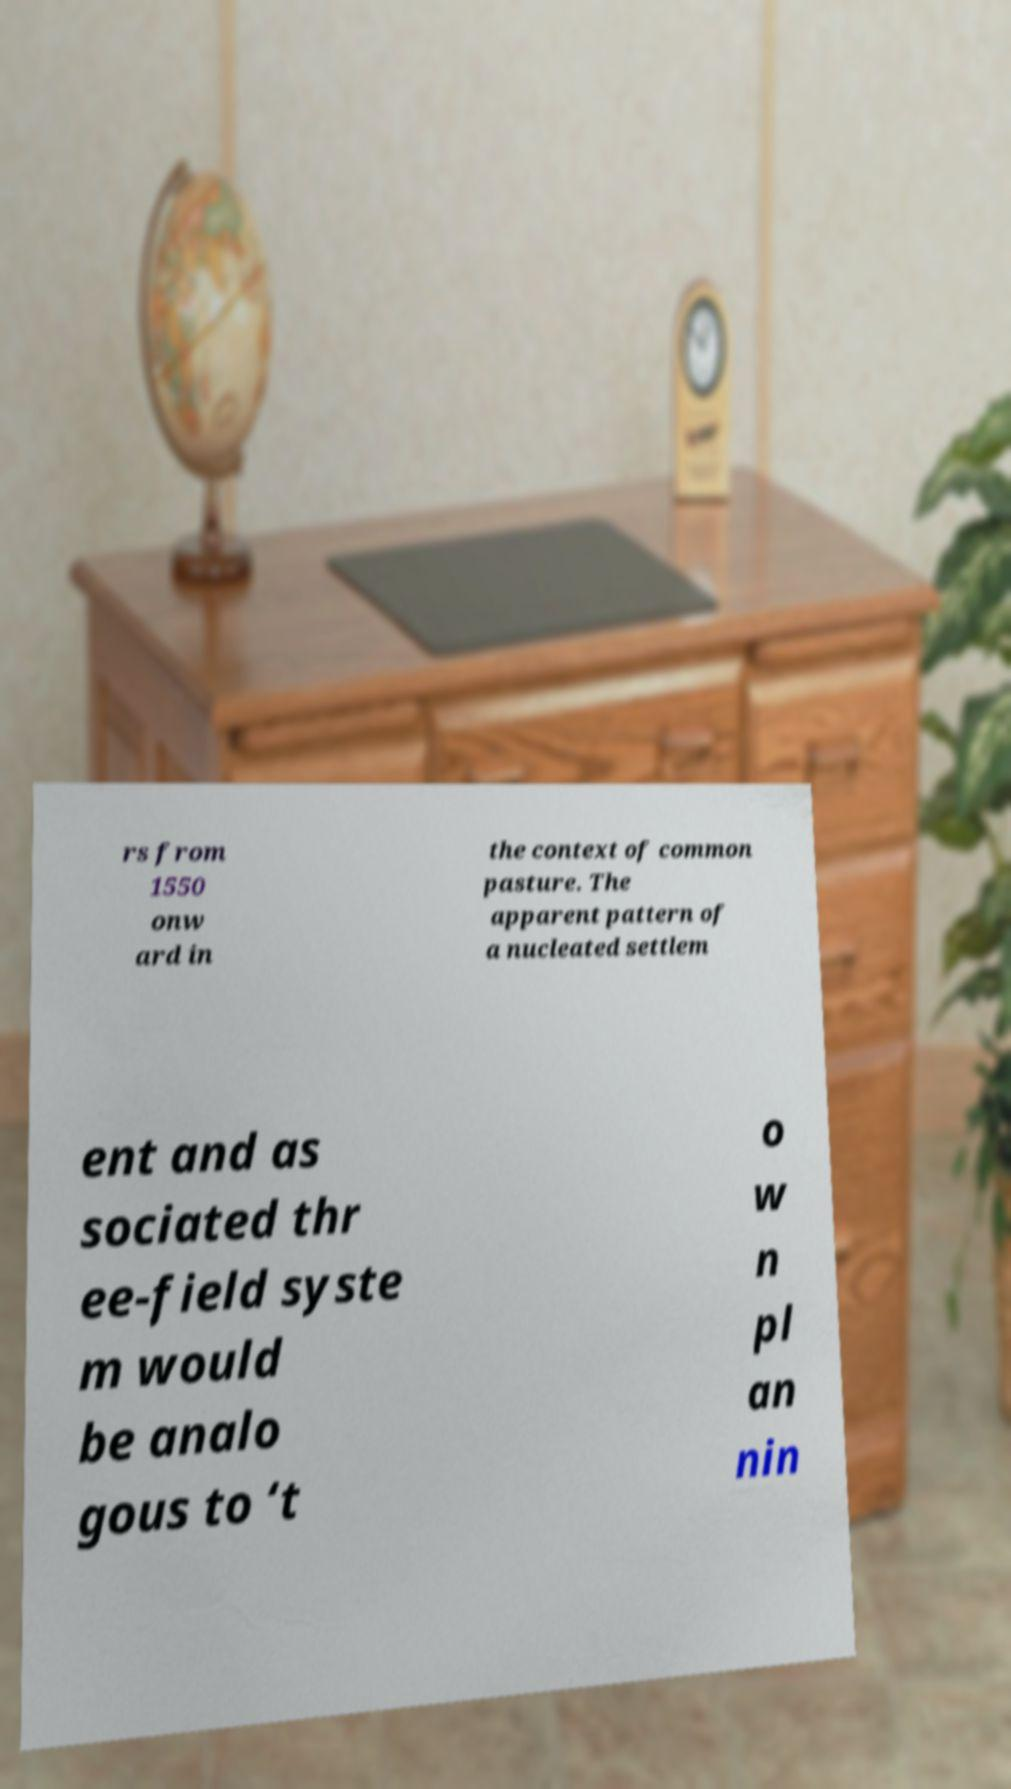What messages or text are displayed in this image? I need them in a readable, typed format. rs from 1550 onw ard in the context of common pasture. The apparent pattern of a nucleated settlem ent and as sociated thr ee-field syste m would be analo gous to ‘t o w n pl an nin 